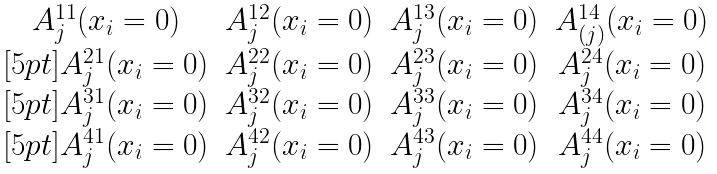<formula> <loc_0><loc_0><loc_500><loc_500>\begin{matrix} A _ { j } ^ { 1 1 } ( x _ { i } = 0 ) & A _ { j } ^ { 1 2 } ( x _ { i } = 0 ) & A _ { j } ^ { 1 3 } ( x _ { i } = 0 ) & A _ { ( j ) } ^ { 1 4 } ( x _ { i } = 0 ) \\ [ 5 p t ] A _ { j } ^ { 2 1 } ( x _ { i } = 0 ) & A _ { j } ^ { 2 2 } ( x _ { i } = 0 ) & A _ { j } ^ { 2 3 } ( x _ { i } = 0 ) & A _ { j } ^ { 2 4 } ( x _ { i } = 0 ) \\ [ 5 p t ] A _ { j } ^ { 3 1 } ( x _ { i } = 0 ) & A _ { j } ^ { 3 2 } ( x _ { i } = 0 ) & A _ { j } ^ { 3 3 } ( x _ { i } = 0 ) & A _ { j } ^ { 3 4 } ( x _ { i } = 0 ) \\ [ 5 p t ] A _ { j } ^ { 4 1 } ( x _ { i } = 0 ) & A _ { j } ^ { 4 2 } ( x _ { i } = 0 ) & A _ { j } ^ { 4 3 } ( x _ { i } = 0 ) & A _ { j } ^ { 4 4 } ( x _ { i } = 0 ) \end{matrix}</formula> 